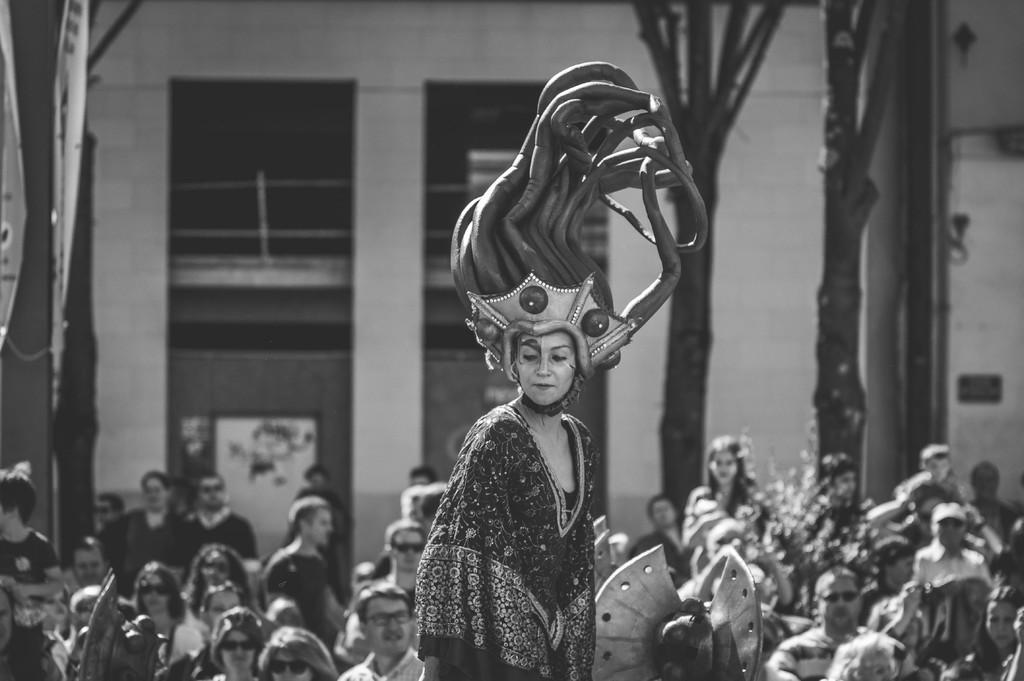What is the main subject of the black and white picture in the image? The main subject of the black and white picture in the image is a woman. What is the woman doing in the picture? The woman is standing in the picture. What is the woman wearing on her head? The woman is wearing a helmet. What can be seen in the background of the image? There is a group of people, a group of trees, and a building in the background of the image. What type of map is the woman holding in the image? There is no map present in the image; the woman is wearing a helmet and standing in a black and white picture. What kind of expert advice is the woman providing in the image? There is no indication in the image that the woman is providing expert advice or any advice at all. 